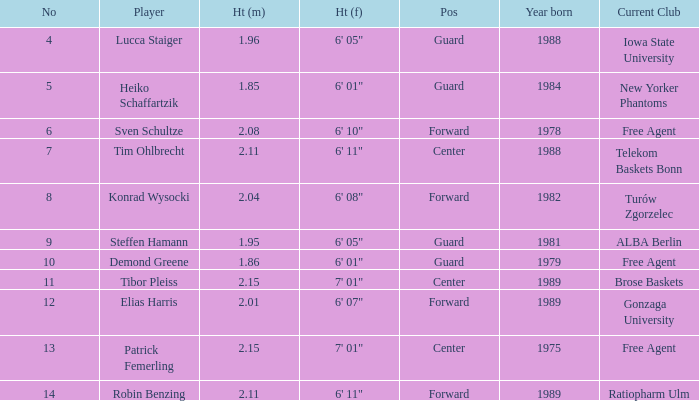Can you provide the height of demond greene? 6' 01". 